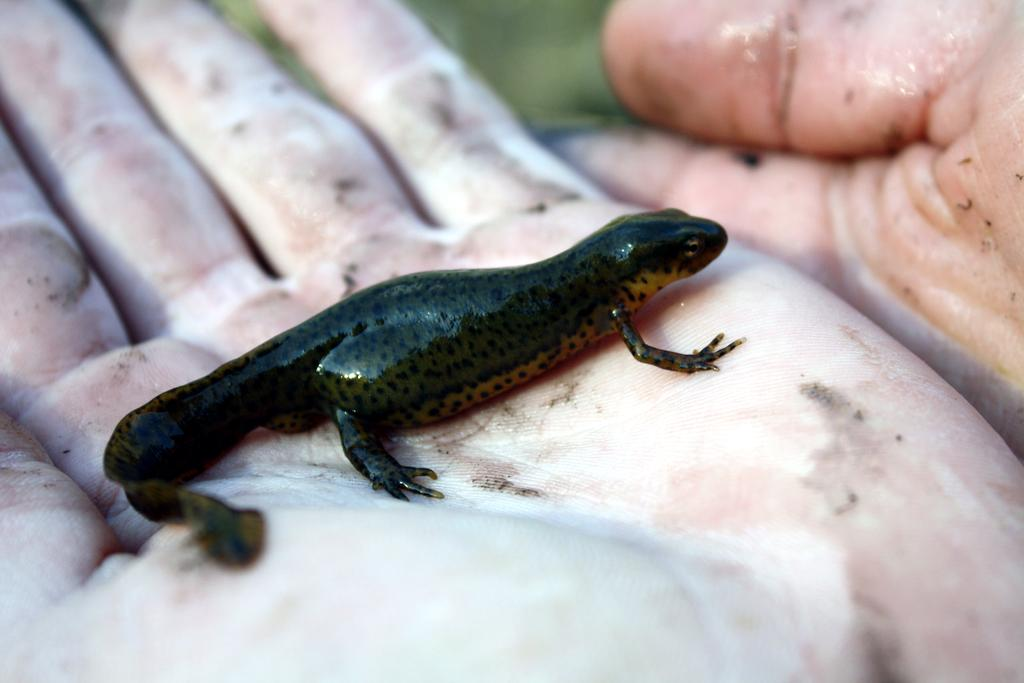What is present in the image? There is a person in the image. What part of the person's body is visible? The person's hands are visible. What is the person holding in their hand? There is a reptile on one of the person's hands. Can you describe the background of the image? The background of the image is blurry. What type of pear is being used to mix the eggnog in the image? There is no pear or eggnog present in the image. 